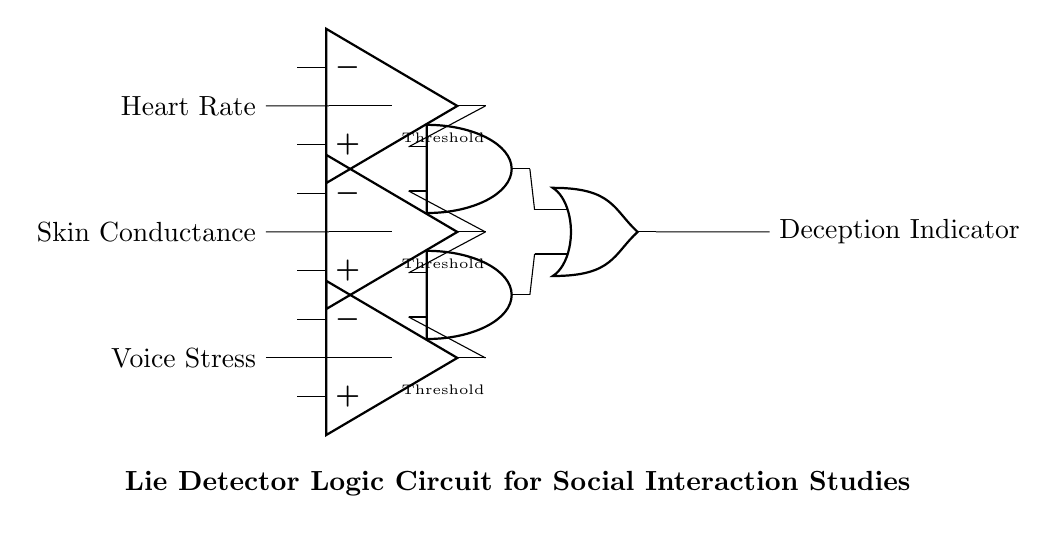What are the input variables of the circuit? The circuit has three input variables: Heart Rate, Skin Conductance, and Voice Stress, as indicated on the left side of the diagram.
Answer: Heart Rate, Skin Conductance, Voice Stress What type of logic gates are used in the circuit? The circuit uses two AND gates and one OR gate for processing the inputs from the comparators. This is evident from the specific symbols shown in the circuit.
Answer: AND gates, OR gate How many comparators are present in the circuit? The circuit has three comparators, as represented by the three operational amplifier symbols on the left side. Each comparator processes one input variable.
Answer: Three What is the final output of the circuit? The final output is labeled as the "Deception Indicator," which is derived from the logic gate outputs. This is indicated at the right side of the diagram.
Answer: Deception Indicator How do the AND gates contribute to the detection of deception? The AND gates combine the outputs from the comparators, treating them as multiple conditions to be met simultaneously, thereby refining the detection mechanism based on several physiological signals.
Answer: By combining conditions What roles do the thresholds serve in this circuit? The thresholds are used to determine the limits for each comparator's output; they signify the level at which the input signal is considered significant for detecting deception.
Answer: They set limits for outputs What is the significance of using an OR gate in this circuit? The OR gate takes the outputs from the two AND gates and provides a final indication of deception if at least one condition is met, showing that multiple factors can indicate a lie.
Answer: Indicates if at least one condition is met 